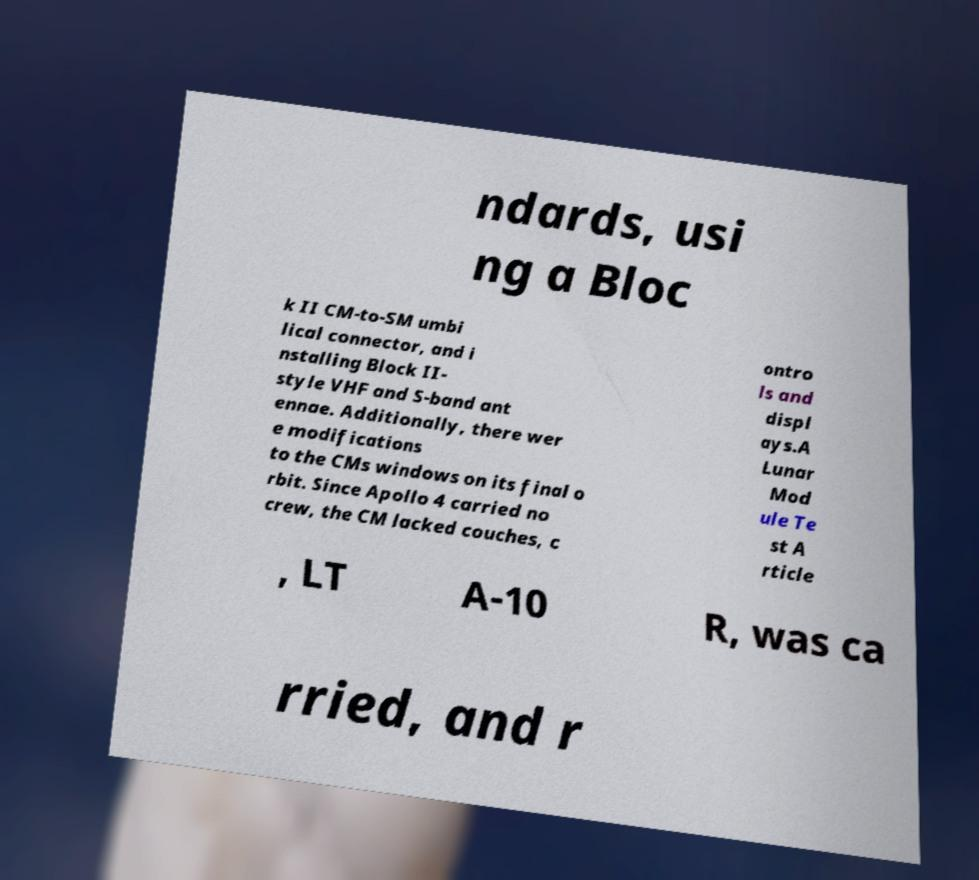Could you assist in decoding the text presented in this image and type it out clearly? ndards, usi ng a Bloc k II CM-to-SM umbi lical connector, and i nstalling Block II- style VHF and S-band ant ennae. Additionally, there wer e modifications to the CMs windows on its final o rbit. Since Apollo 4 carried no crew, the CM lacked couches, c ontro ls and displ ays.A Lunar Mod ule Te st A rticle , LT A-10 R, was ca rried, and r 